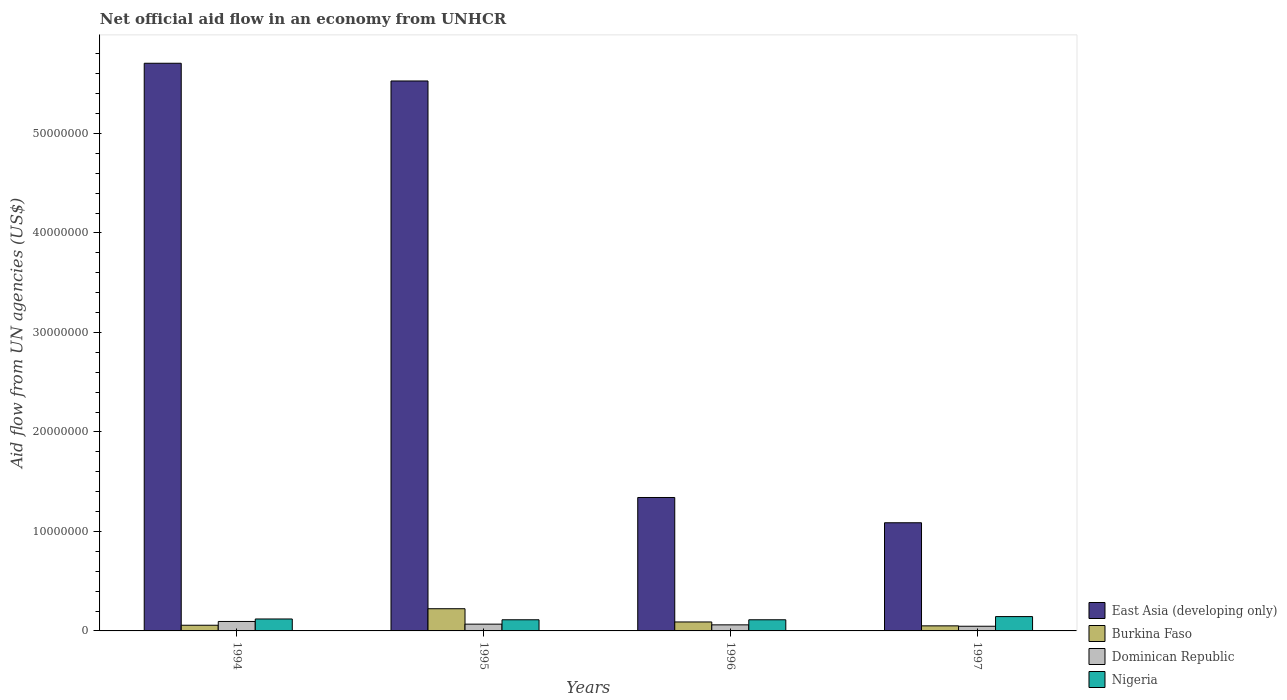How many different coloured bars are there?
Give a very brief answer. 4. Are the number of bars per tick equal to the number of legend labels?
Your response must be concise. Yes. In how many cases, is the number of bars for a given year not equal to the number of legend labels?
Ensure brevity in your answer.  0. What is the net official aid flow in Dominican Republic in 1995?
Your response must be concise. 6.80e+05. Across all years, what is the maximum net official aid flow in East Asia (developing only)?
Ensure brevity in your answer.  5.70e+07. Across all years, what is the minimum net official aid flow in Nigeria?
Make the answer very short. 1.12e+06. In which year was the net official aid flow in Nigeria maximum?
Make the answer very short. 1997. In which year was the net official aid flow in Burkina Faso minimum?
Ensure brevity in your answer.  1997. What is the total net official aid flow in Dominican Republic in the graph?
Provide a short and direct response. 2.71e+06. What is the difference between the net official aid flow in Nigeria in 1994 and that in 1995?
Provide a succinct answer. 8.00e+04. What is the difference between the net official aid flow in Dominican Republic in 1997 and the net official aid flow in Nigeria in 1996?
Give a very brief answer. -6.50e+05. What is the average net official aid flow in Burkina Faso per year?
Offer a very short reply. 1.05e+06. In the year 1997, what is the difference between the net official aid flow in Dominican Republic and net official aid flow in Burkina Faso?
Your answer should be very brief. -4.00e+04. What is the ratio of the net official aid flow in Dominican Republic in 1996 to that in 1997?
Provide a short and direct response. 1.3. Is the net official aid flow in Nigeria in 1996 less than that in 1997?
Offer a terse response. Yes. What is the difference between the highest and the second highest net official aid flow in Burkina Faso?
Your answer should be very brief. 1.33e+06. What is the difference between the highest and the lowest net official aid flow in East Asia (developing only)?
Offer a terse response. 4.62e+07. Is the sum of the net official aid flow in Dominican Republic in 1995 and 1997 greater than the maximum net official aid flow in Nigeria across all years?
Your response must be concise. No. What does the 1st bar from the left in 1997 represents?
Provide a short and direct response. East Asia (developing only). What does the 2nd bar from the right in 1995 represents?
Provide a succinct answer. Dominican Republic. How many bars are there?
Give a very brief answer. 16. How many years are there in the graph?
Make the answer very short. 4. What is the difference between two consecutive major ticks on the Y-axis?
Your answer should be very brief. 1.00e+07. Are the values on the major ticks of Y-axis written in scientific E-notation?
Offer a terse response. No. Does the graph contain grids?
Your response must be concise. No. Where does the legend appear in the graph?
Provide a short and direct response. Bottom right. How many legend labels are there?
Your answer should be compact. 4. How are the legend labels stacked?
Make the answer very short. Vertical. What is the title of the graph?
Offer a very short reply. Net official aid flow in an economy from UNHCR. Does "Upper middle income" appear as one of the legend labels in the graph?
Your answer should be very brief. No. What is the label or title of the Y-axis?
Give a very brief answer. Aid flow from UN agencies (US$). What is the Aid flow from UN agencies (US$) of East Asia (developing only) in 1994?
Provide a succinct answer. 5.70e+07. What is the Aid flow from UN agencies (US$) in Burkina Faso in 1994?
Offer a terse response. 5.70e+05. What is the Aid flow from UN agencies (US$) in Dominican Republic in 1994?
Provide a succinct answer. 9.50e+05. What is the Aid flow from UN agencies (US$) of Nigeria in 1994?
Your answer should be compact. 1.20e+06. What is the Aid flow from UN agencies (US$) in East Asia (developing only) in 1995?
Offer a terse response. 5.53e+07. What is the Aid flow from UN agencies (US$) of Burkina Faso in 1995?
Ensure brevity in your answer.  2.23e+06. What is the Aid flow from UN agencies (US$) in Dominican Republic in 1995?
Make the answer very short. 6.80e+05. What is the Aid flow from UN agencies (US$) of Nigeria in 1995?
Your answer should be very brief. 1.12e+06. What is the Aid flow from UN agencies (US$) of East Asia (developing only) in 1996?
Provide a succinct answer. 1.34e+07. What is the Aid flow from UN agencies (US$) in Burkina Faso in 1996?
Offer a very short reply. 9.00e+05. What is the Aid flow from UN agencies (US$) of Dominican Republic in 1996?
Make the answer very short. 6.10e+05. What is the Aid flow from UN agencies (US$) in Nigeria in 1996?
Offer a terse response. 1.12e+06. What is the Aid flow from UN agencies (US$) in East Asia (developing only) in 1997?
Provide a short and direct response. 1.09e+07. What is the Aid flow from UN agencies (US$) in Burkina Faso in 1997?
Give a very brief answer. 5.10e+05. What is the Aid flow from UN agencies (US$) in Dominican Republic in 1997?
Keep it short and to the point. 4.70e+05. What is the Aid flow from UN agencies (US$) of Nigeria in 1997?
Your answer should be compact. 1.44e+06. Across all years, what is the maximum Aid flow from UN agencies (US$) of East Asia (developing only)?
Your answer should be compact. 5.70e+07. Across all years, what is the maximum Aid flow from UN agencies (US$) in Burkina Faso?
Your answer should be compact. 2.23e+06. Across all years, what is the maximum Aid flow from UN agencies (US$) of Dominican Republic?
Your response must be concise. 9.50e+05. Across all years, what is the maximum Aid flow from UN agencies (US$) in Nigeria?
Keep it short and to the point. 1.44e+06. Across all years, what is the minimum Aid flow from UN agencies (US$) of East Asia (developing only)?
Offer a terse response. 1.09e+07. Across all years, what is the minimum Aid flow from UN agencies (US$) of Burkina Faso?
Give a very brief answer. 5.10e+05. Across all years, what is the minimum Aid flow from UN agencies (US$) in Nigeria?
Provide a succinct answer. 1.12e+06. What is the total Aid flow from UN agencies (US$) in East Asia (developing only) in the graph?
Ensure brevity in your answer.  1.37e+08. What is the total Aid flow from UN agencies (US$) of Burkina Faso in the graph?
Provide a short and direct response. 4.21e+06. What is the total Aid flow from UN agencies (US$) in Dominican Republic in the graph?
Provide a succinct answer. 2.71e+06. What is the total Aid flow from UN agencies (US$) of Nigeria in the graph?
Your response must be concise. 4.88e+06. What is the difference between the Aid flow from UN agencies (US$) of East Asia (developing only) in 1994 and that in 1995?
Ensure brevity in your answer.  1.78e+06. What is the difference between the Aid flow from UN agencies (US$) in Burkina Faso in 1994 and that in 1995?
Offer a very short reply. -1.66e+06. What is the difference between the Aid flow from UN agencies (US$) in East Asia (developing only) in 1994 and that in 1996?
Offer a very short reply. 4.36e+07. What is the difference between the Aid flow from UN agencies (US$) of Burkina Faso in 1994 and that in 1996?
Keep it short and to the point. -3.30e+05. What is the difference between the Aid flow from UN agencies (US$) in Nigeria in 1994 and that in 1996?
Ensure brevity in your answer.  8.00e+04. What is the difference between the Aid flow from UN agencies (US$) in East Asia (developing only) in 1994 and that in 1997?
Your response must be concise. 4.62e+07. What is the difference between the Aid flow from UN agencies (US$) in Burkina Faso in 1994 and that in 1997?
Give a very brief answer. 6.00e+04. What is the difference between the Aid flow from UN agencies (US$) in Dominican Republic in 1994 and that in 1997?
Offer a terse response. 4.80e+05. What is the difference between the Aid flow from UN agencies (US$) of Nigeria in 1994 and that in 1997?
Provide a short and direct response. -2.40e+05. What is the difference between the Aid flow from UN agencies (US$) in East Asia (developing only) in 1995 and that in 1996?
Provide a succinct answer. 4.19e+07. What is the difference between the Aid flow from UN agencies (US$) in Burkina Faso in 1995 and that in 1996?
Make the answer very short. 1.33e+06. What is the difference between the Aid flow from UN agencies (US$) in East Asia (developing only) in 1995 and that in 1997?
Give a very brief answer. 4.44e+07. What is the difference between the Aid flow from UN agencies (US$) in Burkina Faso in 1995 and that in 1997?
Offer a very short reply. 1.72e+06. What is the difference between the Aid flow from UN agencies (US$) of Dominican Republic in 1995 and that in 1997?
Your response must be concise. 2.10e+05. What is the difference between the Aid flow from UN agencies (US$) of Nigeria in 1995 and that in 1997?
Keep it short and to the point. -3.20e+05. What is the difference between the Aid flow from UN agencies (US$) of East Asia (developing only) in 1996 and that in 1997?
Offer a terse response. 2.54e+06. What is the difference between the Aid flow from UN agencies (US$) in Burkina Faso in 1996 and that in 1997?
Provide a short and direct response. 3.90e+05. What is the difference between the Aid flow from UN agencies (US$) of Nigeria in 1996 and that in 1997?
Offer a very short reply. -3.20e+05. What is the difference between the Aid flow from UN agencies (US$) of East Asia (developing only) in 1994 and the Aid flow from UN agencies (US$) of Burkina Faso in 1995?
Make the answer very short. 5.48e+07. What is the difference between the Aid flow from UN agencies (US$) in East Asia (developing only) in 1994 and the Aid flow from UN agencies (US$) in Dominican Republic in 1995?
Provide a succinct answer. 5.64e+07. What is the difference between the Aid flow from UN agencies (US$) of East Asia (developing only) in 1994 and the Aid flow from UN agencies (US$) of Nigeria in 1995?
Provide a short and direct response. 5.59e+07. What is the difference between the Aid flow from UN agencies (US$) in Burkina Faso in 1994 and the Aid flow from UN agencies (US$) in Dominican Republic in 1995?
Provide a succinct answer. -1.10e+05. What is the difference between the Aid flow from UN agencies (US$) in Burkina Faso in 1994 and the Aid flow from UN agencies (US$) in Nigeria in 1995?
Ensure brevity in your answer.  -5.50e+05. What is the difference between the Aid flow from UN agencies (US$) of Dominican Republic in 1994 and the Aid flow from UN agencies (US$) of Nigeria in 1995?
Provide a short and direct response. -1.70e+05. What is the difference between the Aid flow from UN agencies (US$) in East Asia (developing only) in 1994 and the Aid flow from UN agencies (US$) in Burkina Faso in 1996?
Your response must be concise. 5.62e+07. What is the difference between the Aid flow from UN agencies (US$) in East Asia (developing only) in 1994 and the Aid flow from UN agencies (US$) in Dominican Republic in 1996?
Ensure brevity in your answer.  5.64e+07. What is the difference between the Aid flow from UN agencies (US$) of East Asia (developing only) in 1994 and the Aid flow from UN agencies (US$) of Nigeria in 1996?
Ensure brevity in your answer.  5.59e+07. What is the difference between the Aid flow from UN agencies (US$) in Burkina Faso in 1994 and the Aid flow from UN agencies (US$) in Nigeria in 1996?
Make the answer very short. -5.50e+05. What is the difference between the Aid flow from UN agencies (US$) in Dominican Republic in 1994 and the Aid flow from UN agencies (US$) in Nigeria in 1996?
Keep it short and to the point. -1.70e+05. What is the difference between the Aid flow from UN agencies (US$) in East Asia (developing only) in 1994 and the Aid flow from UN agencies (US$) in Burkina Faso in 1997?
Your response must be concise. 5.65e+07. What is the difference between the Aid flow from UN agencies (US$) in East Asia (developing only) in 1994 and the Aid flow from UN agencies (US$) in Dominican Republic in 1997?
Ensure brevity in your answer.  5.66e+07. What is the difference between the Aid flow from UN agencies (US$) in East Asia (developing only) in 1994 and the Aid flow from UN agencies (US$) in Nigeria in 1997?
Your response must be concise. 5.56e+07. What is the difference between the Aid flow from UN agencies (US$) in Burkina Faso in 1994 and the Aid flow from UN agencies (US$) in Nigeria in 1997?
Give a very brief answer. -8.70e+05. What is the difference between the Aid flow from UN agencies (US$) in Dominican Republic in 1994 and the Aid flow from UN agencies (US$) in Nigeria in 1997?
Offer a terse response. -4.90e+05. What is the difference between the Aid flow from UN agencies (US$) in East Asia (developing only) in 1995 and the Aid flow from UN agencies (US$) in Burkina Faso in 1996?
Ensure brevity in your answer.  5.44e+07. What is the difference between the Aid flow from UN agencies (US$) of East Asia (developing only) in 1995 and the Aid flow from UN agencies (US$) of Dominican Republic in 1996?
Provide a short and direct response. 5.47e+07. What is the difference between the Aid flow from UN agencies (US$) in East Asia (developing only) in 1995 and the Aid flow from UN agencies (US$) in Nigeria in 1996?
Your answer should be compact. 5.42e+07. What is the difference between the Aid flow from UN agencies (US$) of Burkina Faso in 1995 and the Aid flow from UN agencies (US$) of Dominican Republic in 1996?
Your response must be concise. 1.62e+06. What is the difference between the Aid flow from UN agencies (US$) in Burkina Faso in 1995 and the Aid flow from UN agencies (US$) in Nigeria in 1996?
Your response must be concise. 1.11e+06. What is the difference between the Aid flow from UN agencies (US$) of Dominican Republic in 1995 and the Aid flow from UN agencies (US$) of Nigeria in 1996?
Your answer should be compact. -4.40e+05. What is the difference between the Aid flow from UN agencies (US$) in East Asia (developing only) in 1995 and the Aid flow from UN agencies (US$) in Burkina Faso in 1997?
Your answer should be compact. 5.48e+07. What is the difference between the Aid flow from UN agencies (US$) in East Asia (developing only) in 1995 and the Aid flow from UN agencies (US$) in Dominican Republic in 1997?
Your answer should be very brief. 5.48e+07. What is the difference between the Aid flow from UN agencies (US$) in East Asia (developing only) in 1995 and the Aid flow from UN agencies (US$) in Nigeria in 1997?
Keep it short and to the point. 5.38e+07. What is the difference between the Aid flow from UN agencies (US$) of Burkina Faso in 1995 and the Aid flow from UN agencies (US$) of Dominican Republic in 1997?
Keep it short and to the point. 1.76e+06. What is the difference between the Aid flow from UN agencies (US$) in Burkina Faso in 1995 and the Aid flow from UN agencies (US$) in Nigeria in 1997?
Ensure brevity in your answer.  7.90e+05. What is the difference between the Aid flow from UN agencies (US$) in Dominican Republic in 1995 and the Aid flow from UN agencies (US$) in Nigeria in 1997?
Keep it short and to the point. -7.60e+05. What is the difference between the Aid flow from UN agencies (US$) of East Asia (developing only) in 1996 and the Aid flow from UN agencies (US$) of Burkina Faso in 1997?
Provide a succinct answer. 1.29e+07. What is the difference between the Aid flow from UN agencies (US$) of East Asia (developing only) in 1996 and the Aid flow from UN agencies (US$) of Dominican Republic in 1997?
Your response must be concise. 1.29e+07. What is the difference between the Aid flow from UN agencies (US$) in East Asia (developing only) in 1996 and the Aid flow from UN agencies (US$) in Nigeria in 1997?
Provide a short and direct response. 1.20e+07. What is the difference between the Aid flow from UN agencies (US$) of Burkina Faso in 1996 and the Aid flow from UN agencies (US$) of Nigeria in 1997?
Provide a succinct answer. -5.40e+05. What is the difference between the Aid flow from UN agencies (US$) in Dominican Republic in 1996 and the Aid flow from UN agencies (US$) in Nigeria in 1997?
Your answer should be very brief. -8.30e+05. What is the average Aid flow from UN agencies (US$) of East Asia (developing only) per year?
Offer a very short reply. 3.42e+07. What is the average Aid flow from UN agencies (US$) of Burkina Faso per year?
Provide a succinct answer. 1.05e+06. What is the average Aid flow from UN agencies (US$) of Dominican Republic per year?
Make the answer very short. 6.78e+05. What is the average Aid flow from UN agencies (US$) in Nigeria per year?
Give a very brief answer. 1.22e+06. In the year 1994, what is the difference between the Aid flow from UN agencies (US$) in East Asia (developing only) and Aid flow from UN agencies (US$) in Burkina Faso?
Your response must be concise. 5.65e+07. In the year 1994, what is the difference between the Aid flow from UN agencies (US$) of East Asia (developing only) and Aid flow from UN agencies (US$) of Dominican Republic?
Provide a short and direct response. 5.61e+07. In the year 1994, what is the difference between the Aid flow from UN agencies (US$) of East Asia (developing only) and Aid flow from UN agencies (US$) of Nigeria?
Offer a very short reply. 5.58e+07. In the year 1994, what is the difference between the Aid flow from UN agencies (US$) of Burkina Faso and Aid flow from UN agencies (US$) of Dominican Republic?
Make the answer very short. -3.80e+05. In the year 1994, what is the difference between the Aid flow from UN agencies (US$) in Burkina Faso and Aid flow from UN agencies (US$) in Nigeria?
Offer a very short reply. -6.30e+05. In the year 1995, what is the difference between the Aid flow from UN agencies (US$) of East Asia (developing only) and Aid flow from UN agencies (US$) of Burkina Faso?
Ensure brevity in your answer.  5.30e+07. In the year 1995, what is the difference between the Aid flow from UN agencies (US$) of East Asia (developing only) and Aid flow from UN agencies (US$) of Dominican Republic?
Keep it short and to the point. 5.46e+07. In the year 1995, what is the difference between the Aid flow from UN agencies (US$) of East Asia (developing only) and Aid flow from UN agencies (US$) of Nigeria?
Provide a succinct answer. 5.42e+07. In the year 1995, what is the difference between the Aid flow from UN agencies (US$) in Burkina Faso and Aid flow from UN agencies (US$) in Dominican Republic?
Provide a short and direct response. 1.55e+06. In the year 1995, what is the difference between the Aid flow from UN agencies (US$) of Burkina Faso and Aid flow from UN agencies (US$) of Nigeria?
Your answer should be very brief. 1.11e+06. In the year 1995, what is the difference between the Aid flow from UN agencies (US$) of Dominican Republic and Aid flow from UN agencies (US$) of Nigeria?
Make the answer very short. -4.40e+05. In the year 1996, what is the difference between the Aid flow from UN agencies (US$) of East Asia (developing only) and Aid flow from UN agencies (US$) of Burkina Faso?
Provide a succinct answer. 1.25e+07. In the year 1996, what is the difference between the Aid flow from UN agencies (US$) in East Asia (developing only) and Aid flow from UN agencies (US$) in Dominican Republic?
Make the answer very short. 1.28e+07. In the year 1996, what is the difference between the Aid flow from UN agencies (US$) in East Asia (developing only) and Aid flow from UN agencies (US$) in Nigeria?
Make the answer very short. 1.23e+07. In the year 1996, what is the difference between the Aid flow from UN agencies (US$) of Burkina Faso and Aid flow from UN agencies (US$) of Dominican Republic?
Give a very brief answer. 2.90e+05. In the year 1996, what is the difference between the Aid flow from UN agencies (US$) in Burkina Faso and Aid flow from UN agencies (US$) in Nigeria?
Provide a succinct answer. -2.20e+05. In the year 1996, what is the difference between the Aid flow from UN agencies (US$) of Dominican Republic and Aid flow from UN agencies (US$) of Nigeria?
Give a very brief answer. -5.10e+05. In the year 1997, what is the difference between the Aid flow from UN agencies (US$) of East Asia (developing only) and Aid flow from UN agencies (US$) of Burkina Faso?
Offer a very short reply. 1.04e+07. In the year 1997, what is the difference between the Aid flow from UN agencies (US$) in East Asia (developing only) and Aid flow from UN agencies (US$) in Dominican Republic?
Give a very brief answer. 1.04e+07. In the year 1997, what is the difference between the Aid flow from UN agencies (US$) of East Asia (developing only) and Aid flow from UN agencies (US$) of Nigeria?
Your answer should be compact. 9.43e+06. In the year 1997, what is the difference between the Aid flow from UN agencies (US$) of Burkina Faso and Aid flow from UN agencies (US$) of Nigeria?
Provide a short and direct response. -9.30e+05. In the year 1997, what is the difference between the Aid flow from UN agencies (US$) of Dominican Republic and Aid flow from UN agencies (US$) of Nigeria?
Offer a terse response. -9.70e+05. What is the ratio of the Aid flow from UN agencies (US$) in East Asia (developing only) in 1994 to that in 1995?
Provide a succinct answer. 1.03. What is the ratio of the Aid flow from UN agencies (US$) of Burkina Faso in 1994 to that in 1995?
Offer a very short reply. 0.26. What is the ratio of the Aid flow from UN agencies (US$) of Dominican Republic in 1994 to that in 1995?
Offer a terse response. 1.4. What is the ratio of the Aid flow from UN agencies (US$) in Nigeria in 1994 to that in 1995?
Ensure brevity in your answer.  1.07. What is the ratio of the Aid flow from UN agencies (US$) in East Asia (developing only) in 1994 to that in 1996?
Give a very brief answer. 4.25. What is the ratio of the Aid flow from UN agencies (US$) in Burkina Faso in 1994 to that in 1996?
Ensure brevity in your answer.  0.63. What is the ratio of the Aid flow from UN agencies (US$) of Dominican Republic in 1994 to that in 1996?
Your answer should be very brief. 1.56. What is the ratio of the Aid flow from UN agencies (US$) of Nigeria in 1994 to that in 1996?
Offer a terse response. 1.07. What is the ratio of the Aid flow from UN agencies (US$) in East Asia (developing only) in 1994 to that in 1997?
Provide a succinct answer. 5.25. What is the ratio of the Aid flow from UN agencies (US$) of Burkina Faso in 1994 to that in 1997?
Your answer should be compact. 1.12. What is the ratio of the Aid flow from UN agencies (US$) in Dominican Republic in 1994 to that in 1997?
Your response must be concise. 2.02. What is the ratio of the Aid flow from UN agencies (US$) in East Asia (developing only) in 1995 to that in 1996?
Your answer should be compact. 4.12. What is the ratio of the Aid flow from UN agencies (US$) in Burkina Faso in 1995 to that in 1996?
Offer a terse response. 2.48. What is the ratio of the Aid flow from UN agencies (US$) of Dominican Republic in 1995 to that in 1996?
Your answer should be compact. 1.11. What is the ratio of the Aid flow from UN agencies (US$) of Nigeria in 1995 to that in 1996?
Provide a short and direct response. 1. What is the ratio of the Aid flow from UN agencies (US$) of East Asia (developing only) in 1995 to that in 1997?
Keep it short and to the point. 5.08. What is the ratio of the Aid flow from UN agencies (US$) in Burkina Faso in 1995 to that in 1997?
Your response must be concise. 4.37. What is the ratio of the Aid flow from UN agencies (US$) in Dominican Republic in 1995 to that in 1997?
Your answer should be very brief. 1.45. What is the ratio of the Aid flow from UN agencies (US$) in Nigeria in 1995 to that in 1997?
Give a very brief answer. 0.78. What is the ratio of the Aid flow from UN agencies (US$) in East Asia (developing only) in 1996 to that in 1997?
Your answer should be compact. 1.23. What is the ratio of the Aid flow from UN agencies (US$) in Burkina Faso in 1996 to that in 1997?
Provide a short and direct response. 1.76. What is the ratio of the Aid flow from UN agencies (US$) of Dominican Republic in 1996 to that in 1997?
Ensure brevity in your answer.  1.3. What is the ratio of the Aid flow from UN agencies (US$) in Nigeria in 1996 to that in 1997?
Provide a succinct answer. 0.78. What is the difference between the highest and the second highest Aid flow from UN agencies (US$) in East Asia (developing only)?
Your response must be concise. 1.78e+06. What is the difference between the highest and the second highest Aid flow from UN agencies (US$) of Burkina Faso?
Your response must be concise. 1.33e+06. What is the difference between the highest and the second highest Aid flow from UN agencies (US$) in Dominican Republic?
Make the answer very short. 2.70e+05. What is the difference between the highest and the second highest Aid flow from UN agencies (US$) in Nigeria?
Provide a short and direct response. 2.40e+05. What is the difference between the highest and the lowest Aid flow from UN agencies (US$) in East Asia (developing only)?
Your response must be concise. 4.62e+07. What is the difference between the highest and the lowest Aid flow from UN agencies (US$) of Burkina Faso?
Your response must be concise. 1.72e+06. 